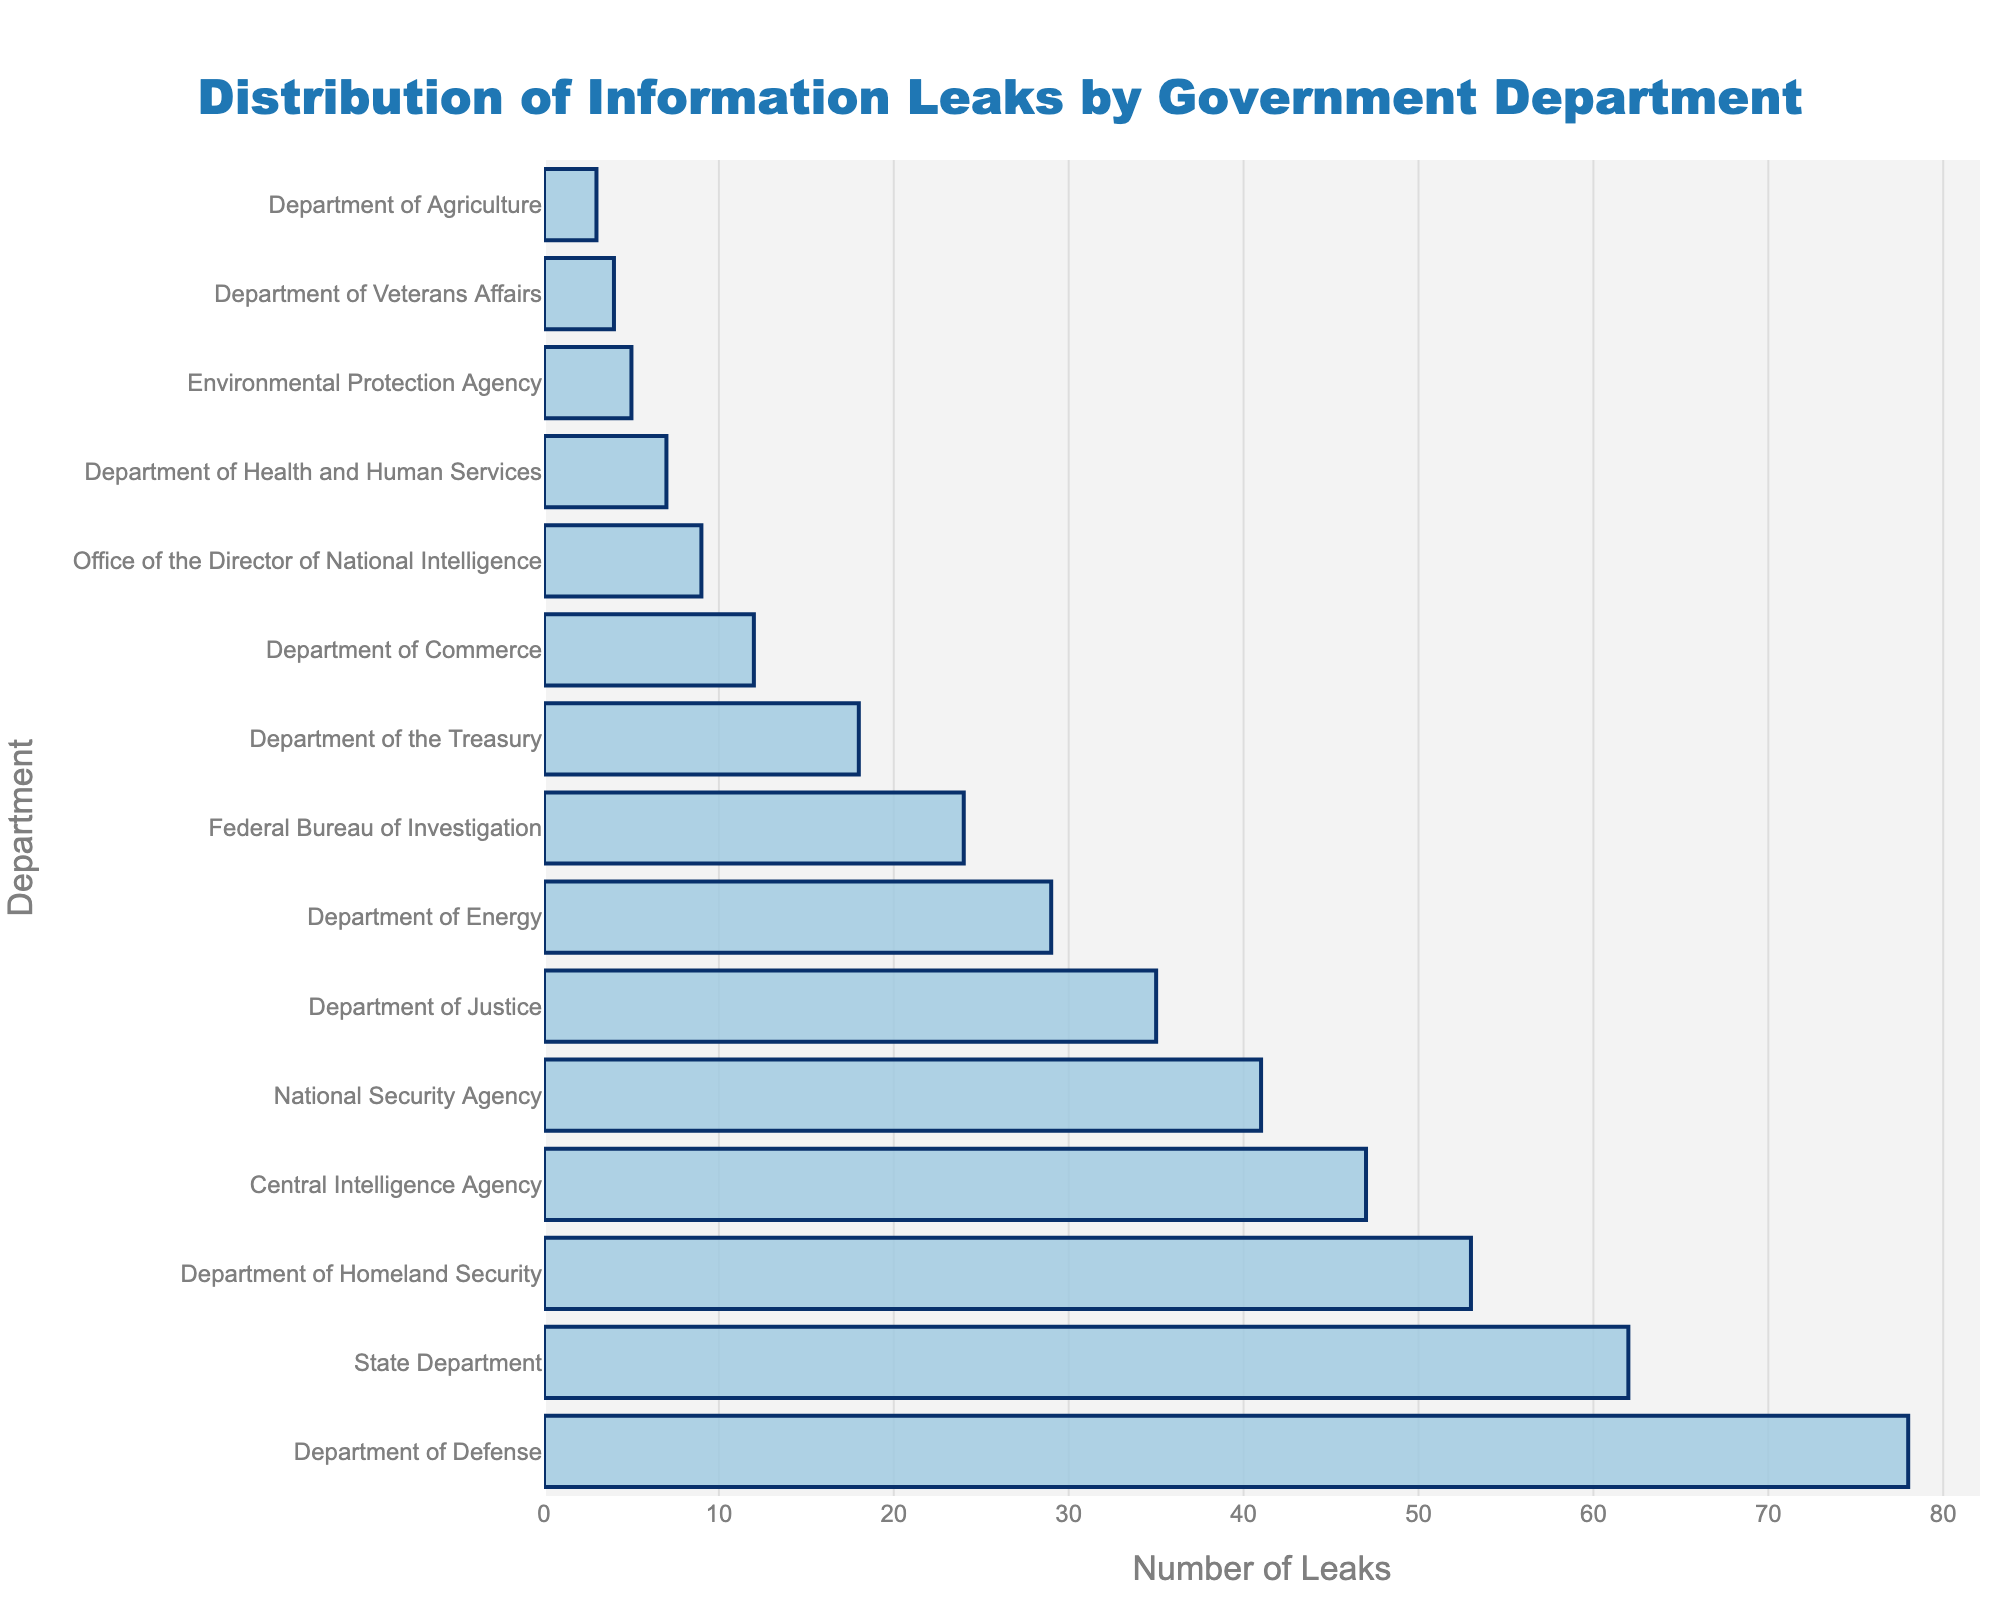Which department has the highest number of information leaks? The bar chart shows that the Department of Defense has the tallest bar, indicating it has the highest number of information leaks.
Answer: Department of Defense Which department has fewer leaks, the Department of Veterans Affairs or the Department of Agriculture? The bar representing the Department of Agriculture is shorter than that of the Department of Veterans Affairs, indicating it has fewer leaks.
Answer: Department of Agriculture What is the combined number of leaks for the State Department and the Department of Homeland Security? The chart shows that the State Department has 62 leaks and the Department of Homeland Security has 53 leaks. Adding them together gives 62 + 53.
Answer: 115 Is the number of leaks in the Department of Justice greater than or less than half the number of leaks in the Department of Defense? The Department of Justice has 35 leaks, while the Department of Defense has 78. Half of 78 is 39, which is greater than 35.
Answer: Less than How many more leaks does the Central Intelligence Agency have compared to the Department of Energy? The Central Intelligence Agency has 47 leaks, while the Department of Energy has 29. The difference is 47 - 29.
Answer: 18 What is the median number of leaks among all the departments listed? To find the median, list all the department leak numbers in ascending order and find the middle value. The numbers in ascending order are 3, 4, 5, 7, 9, 12, 18, 24, 29, 35, 41, 47, 53, 62, 78. The middle value is the 8th number in this list, which is 24.
Answer: 24 Does the Environmental Protection Agency have more leaks than the Department of Veterans Affairs and the Department of Agriculture combined? The Environmental Protection Agency has 5 leaks, while the Department of Veterans Affairs and the Department of Agriculture combined have 4 + 3 = 7 leaks.
Answer: No Rank the departments in the top three positions based on the number of leaks they experienced. The top three departments with the highest number of leaks are the Department of Defense (78), State Department (62), and Department of Homeland Security (53).
Answer: Department of Defense, State Department, Department of Homeland Security What is the difference in the number of leaks between the Federal Bureau of Investigation and the Office of the Director of National Intelligence? The Federal Bureau of Investigation has 24 leaks, and the Office of the Director of National Intelligence has 9. The difference is 24 - 9.
Answer: 15 How many departments have fewer than 10 leaks? By counting the departments with fewer than 10 leaks from the bar chart: Office of the Director of National Intelligence (9), Department of Health and Human Services (7), Environmental Protection Agency (5), Department of Veterans Affairs (4), Department of Agriculture (3), there are 5 departments.
Answer: 5 